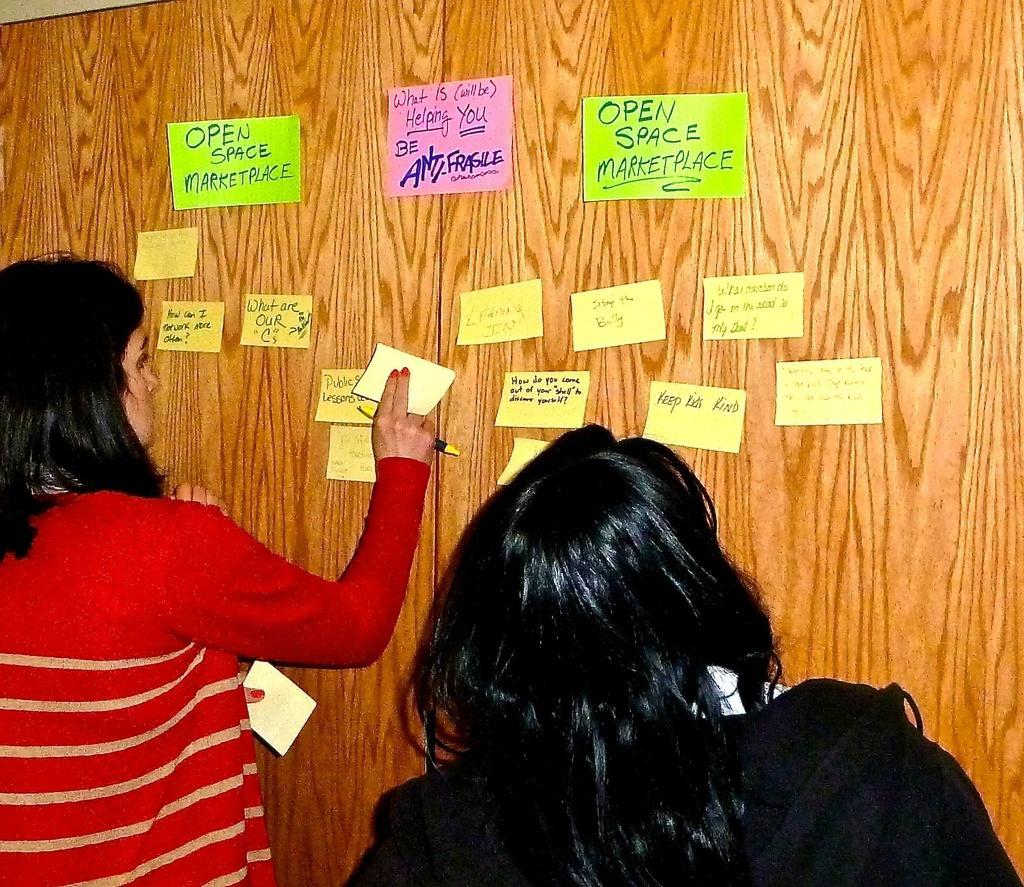Please provide a concise description of this image. In this image we can see women standing. One woman is holding papers and a pen in her hands. In the background, we can see group of papers with some text pasted on the wooden surface. 